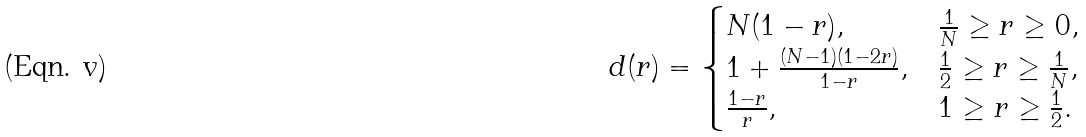<formula> <loc_0><loc_0><loc_500><loc_500>d ( r ) & = \begin{cases} N ( 1 - r ) , & \frac { 1 } { N } \geq r \geq 0 , \\ 1 + \frac { ( N - 1 ) ( 1 - 2 r ) } { 1 - r } , & \frac { 1 } { 2 } \geq r \geq \frac { 1 } { N } , \\ \frac { 1 - r } { r } , & 1 \geq r \geq \frac { 1 } { 2 } . \end{cases}</formula> 